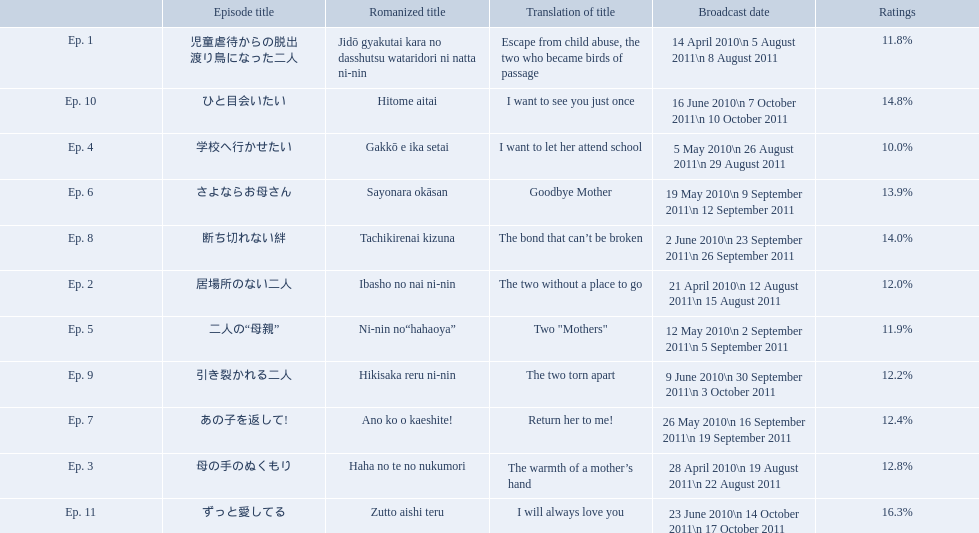What were all the episode titles for the show mother? 児童虐待からの脱出 渡り鳥になった二人, 居場所のない二人, 母の手のぬくもり, 学校へ行かせたい, 二人の“母親”, さよならお母さん, あの子を返して!, 断ち切れない絆, 引き裂かれる二人, ひと目会いたい, ずっと愛してる. What were all the translated episode titles for the show mother? Escape from child abuse, the two who became birds of passage, The two without a place to go, The warmth of a mother’s hand, I want to let her attend school, Two "Mothers", Goodbye Mother, Return her to me!, The bond that can’t be broken, The two torn apart, I want to see you just once, I will always love you. Which episode was translated to i want to let her attend school? Ep. 4. What are all the titles the episodes of the mother tv series? 児童虐待からの脱出 渡り鳥になった二人, 居場所のない二人, 母の手のぬくもり, 学校へ行かせたい, 二人の“母親”, さよならお母さん, あの子を返して!, 断ち切れない絆, 引き裂かれる二人, ひと目会いたい, ずっと愛してる. What are all of the ratings for each of the shows? 11.8%, 12.0%, 12.8%, 10.0%, 11.9%, 13.9%, 12.4%, 14.0%, 12.2%, 14.8%, 16.3%. What is the highest score for ratings? 16.3%. What episode corresponds to that rating? ずっと愛してる. What is the name of epsiode 8? 断ち切れない絆. What were this episodes ratings? 14.0%. 